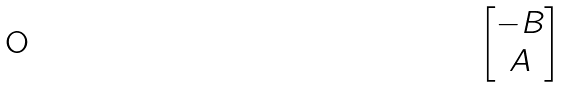<formula> <loc_0><loc_0><loc_500><loc_500>\begin{bmatrix} - B \\ A \end{bmatrix}</formula> 